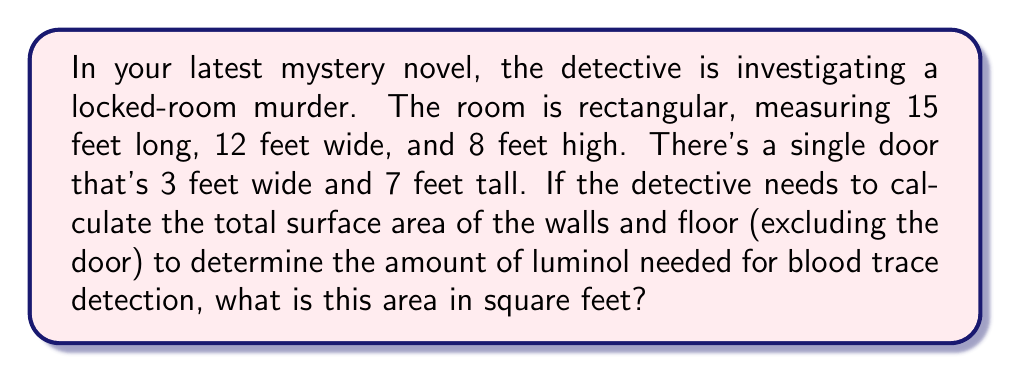Show me your answer to this math problem. Let's break this down step-by-step:

1) First, we need to calculate the area of each surface:

   Floor: $15 \text{ ft} \times 12 \text{ ft} = 180 \text{ sq ft}$

   Ceiling: We don't need this as per the question.

   Long walls (2): $15 \text{ ft} \times 8 \text{ ft} = 120 \text{ sq ft}$ each
   Total for long walls: $120 \times 2 = 240 \text{ sq ft}$

   Short walls (2): $12 \text{ ft} \times 8 \text{ ft} = 96 \text{ sq ft}$ each
   Total for short walls: $96 \times 2 = 192 \text{ sq ft}$

2) Now, we sum up all these areas:

   $$ \text{Total Area} = 180 + 240 + 192 = 612 \text{ sq ft} $$

3) However, we need to subtract the area of the door:

   Door area: $3 \text{ ft} \times 7 \text{ ft} = 21 \text{ sq ft}$

4) Therefore, the final area is:

   $$ \text{Final Area} = 612 - 21 = 591 \text{ sq ft} $$

This is the total surface area of the walls and floor, excluding the door, that needs to be treated with luminol.
Answer: $591 \text{ sq ft}$ 